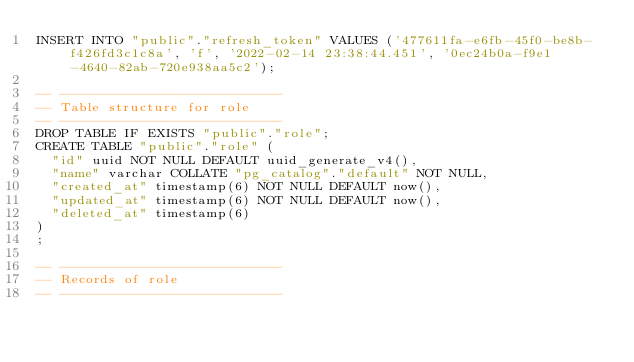<code> <loc_0><loc_0><loc_500><loc_500><_SQL_>INSERT INTO "public"."refresh_token" VALUES ('477611fa-e6fb-45f0-be8b-f426fd3c1c8a', 'f', '2022-02-14 23:38:44.451', '0ec24b0a-f9e1-4640-82ab-720e938aa5c2');

-- ----------------------------
-- Table structure for role
-- ----------------------------
DROP TABLE IF EXISTS "public"."role";
CREATE TABLE "public"."role" (
  "id" uuid NOT NULL DEFAULT uuid_generate_v4(),
  "name" varchar COLLATE "pg_catalog"."default" NOT NULL,
  "created_at" timestamp(6) NOT NULL DEFAULT now(),
  "updated_at" timestamp(6) NOT NULL DEFAULT now(),
  "deleted_at" timestamp(6)
)
;

-- ----------------------------
-- Records of role
-- ----------------------------</code> 